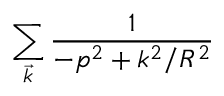<formula> <loc_0><loc_0><loc_500><loc_500>\sum _ { \vec { k } } \frac { 1 } { - p ^ { 2 } + k ^ { 2 } / R ^ { 2 } }</formula> 